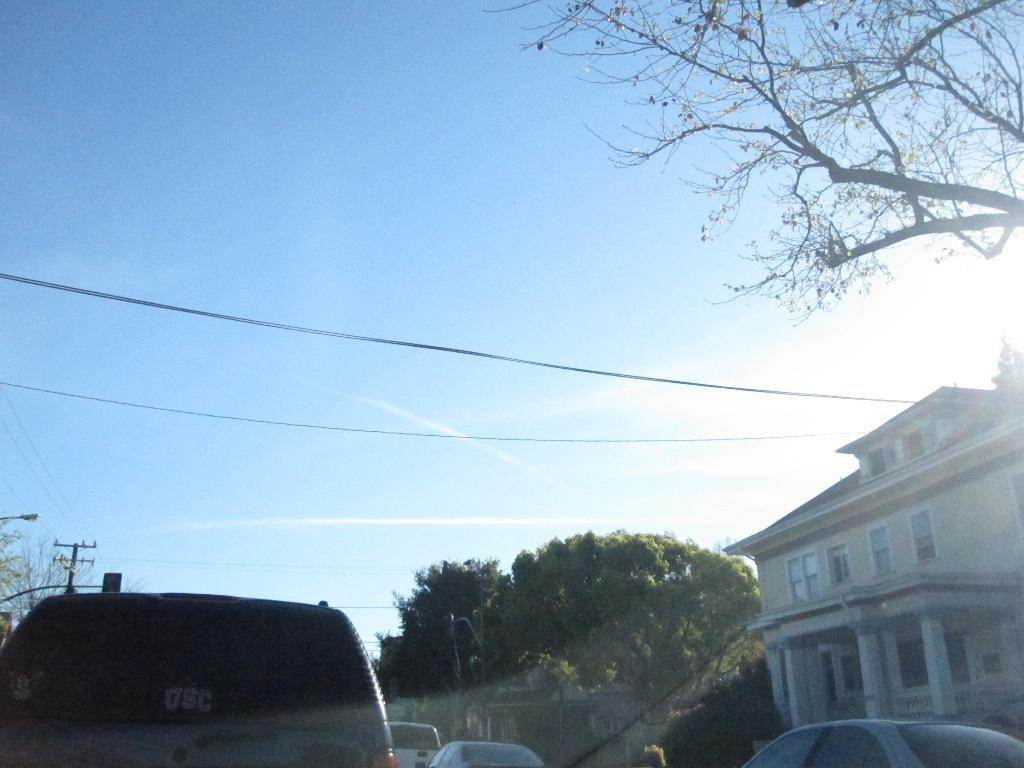What type of natural elements can be seen in the image? There are trees in the image. What type of man-made structures are visible in the image? There are buildings in the image. What type of lighting is present in the image? A street light is present in the image. What type of infrastructure is present in the image? There is a pole with wires attached to it in the image. What is visible in the background of the image? The sky is visible in the background of the image. How many chairs are placed around the breakfast table in the image? There are no chairs or breakfast table present in the image. What type of wrist accessory is visible on the person in the image? There is no person or wrist accessory present in the image. 